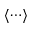Convert formula to latex. <formula><loc_0><loc_0><loc_500><loc_500>\langle \cdots \rangle</formula> 